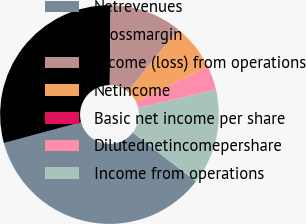Convert chart. <chart><loc_0><loc_0><loc_500><loc_500><pie_chart><fcel>Netrevenues<fcel>Grossmargin<fcel>Income (loss) from operations<fcel>Netincome<fcel>Basic net income per share<fcel>Dilutednetincomepershare<fcel>Income from operations<nl><fcel>35.32%<fcel>29.36%<fcel>10.6%<fcel>7.06%<fcel>0.0%<fcel>3.53%<fcel>14.13%<nl></chart> 